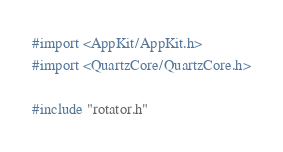<code> <loc_0><loc_0><loc_500><loc_500><_ObjectiveC_>#import <AppKit/AppKit.h>
#import <QuartzCore/QuartzCore.h>

#include "rotator.h"
</code> 